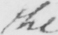Can you read and transcribe this handwriting? the 